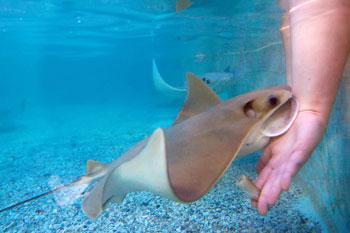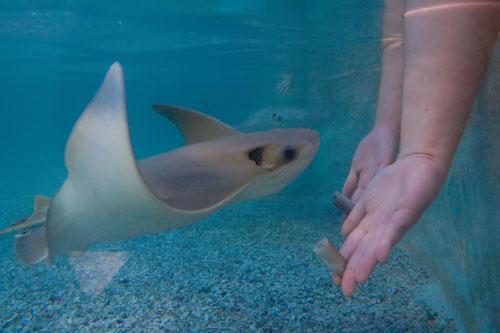The first image is the image on the left, the second image is the image on the right. For the images shown, is this caption "A person is touching a ray with their hand." true? Answer yes or no. Yes. The first image is the image on the left, the second image is the image on the right. Considering the images on both sides, is "The image on the left contains a persons hand stroking a small string ray." valid? Answer yes or no. Yes. 